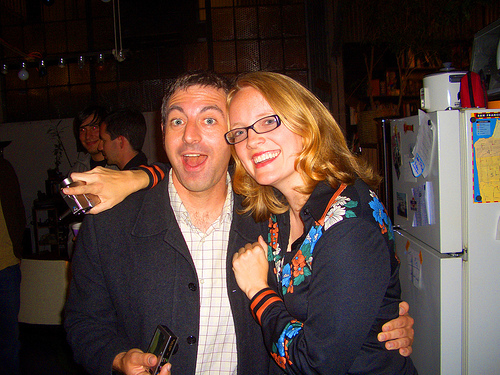<image>What clothing item on the woman is the same color as the man's shirt? It is ambiguous what clothing item on the woman is the same color as the man's shirt, since I can't visualize the image. What clothing item on the woman is the same color as the man's shirt? I don't know what clothing item on the woman is the same color as the man's shirt. It can be the shirt or blouse. 